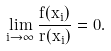Convert formula to latex. <formula><loc_0><loc_0><loc_500><loc_500>\lim _ { i \to \infty } \frac { f ( x _ { i } ) } { r ( x _ { i } ) } = 0 .</formula> 